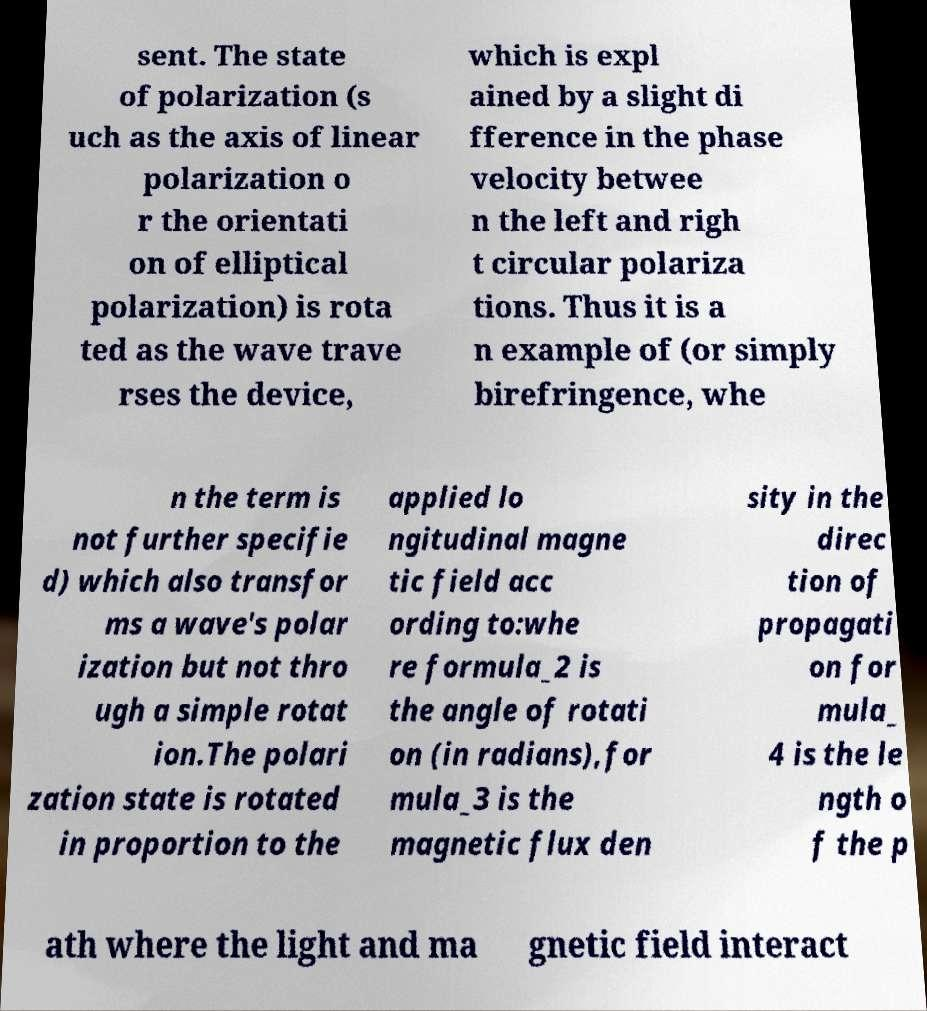Can you accurately transcribe the text from the provided image for me? sent. The state of polarization (s uch as the axis of linear polarization o r the orientati on of elliptical polarization) is rota ted as the wave trave rses the device, which is expl ained by a slight di fference in the phase velocity betwee n the left and righ t circular polariza tions. Thus it is a n example of (or simply birefringence, whe n the term is not further specifie d) which also transfor ms a wave's polar ization but not thro ugh a simple rotat ion.The polari zation state is rotated in proportion to the applied lo ngitudinal magne tic field acc ording to:whe re formula_2 is the angle of rotati on (in radians),for mula_3 is the magnetic flux den sity in the direc tion of propagati on for mula_ 4 is the le ngth o f the p ath where the light and ma gnetic field interact 